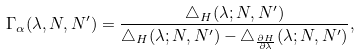<formula> <loc_0><loc_0><loc_500><loc_500>\Gamma _ { \alpha } ( \lambda , N , N ^ { \prime } ) = \frac { \triangle _ { H } ( \lambda ; N , N ^ { \prime } ) } { \triangle _ { H } ( \lambda ; N , N ^ { \prime } ) - \triangle _ { \frac { \partial H } { \partial \lambda } } ( \lambda ; N , N ^ { \prime } ) } ,</formula> 